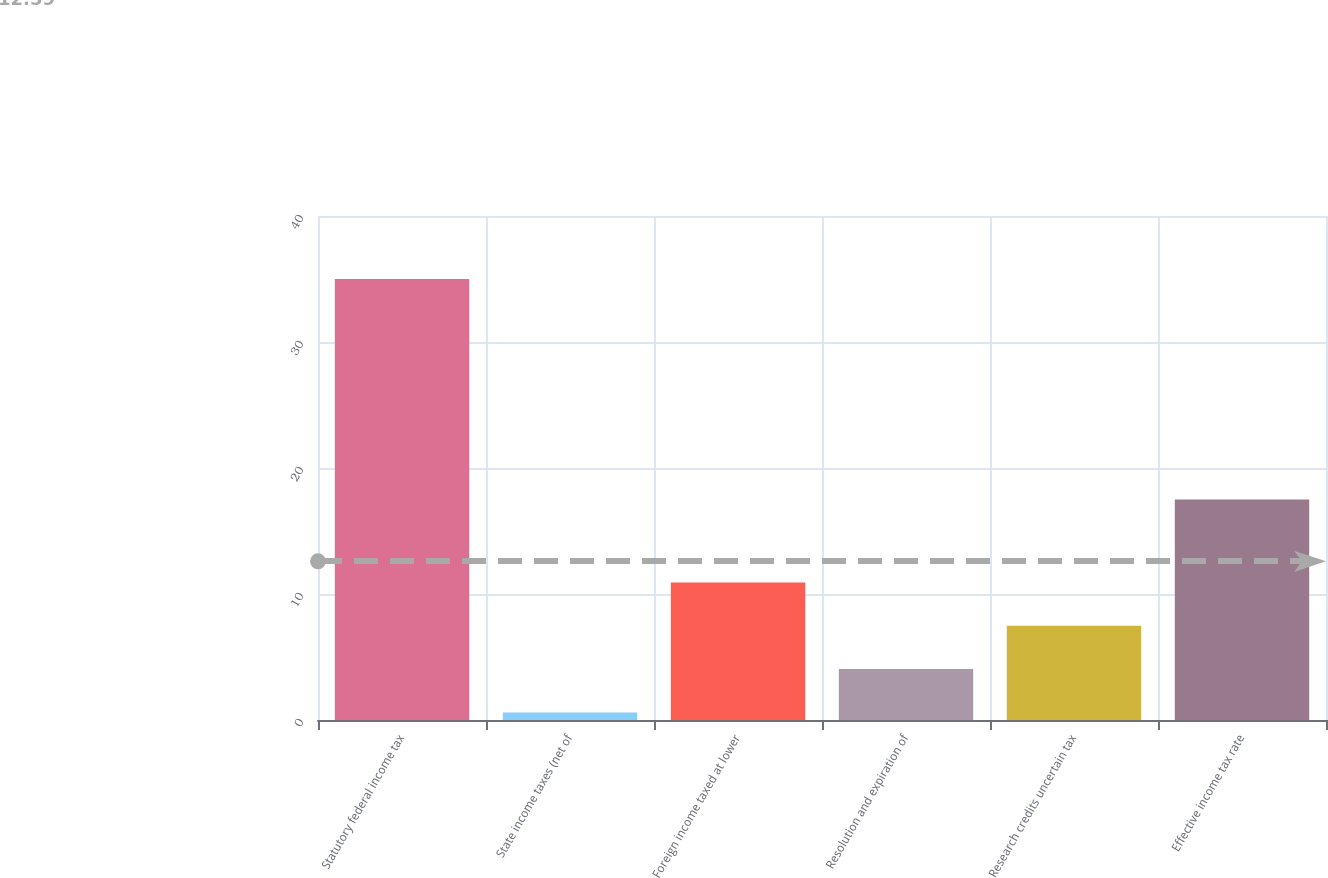Convert chart to OTSL. <chart><loc_0><loc_0><loc_500><loc_500><bar_chart><fcel>Statutory federal income tax<fcel>State income taxes (net of<fcel>Foreign income taxed at lower<fcel>Resolution and expiration of<fcel>Research credits uncertain tax<fcel>Effective income tax rate<nl><fcel>35<fcel>0.6<fcel>10.92<fcel>4.04<fcel>7.48<fcel>17.5<nl></chart> 